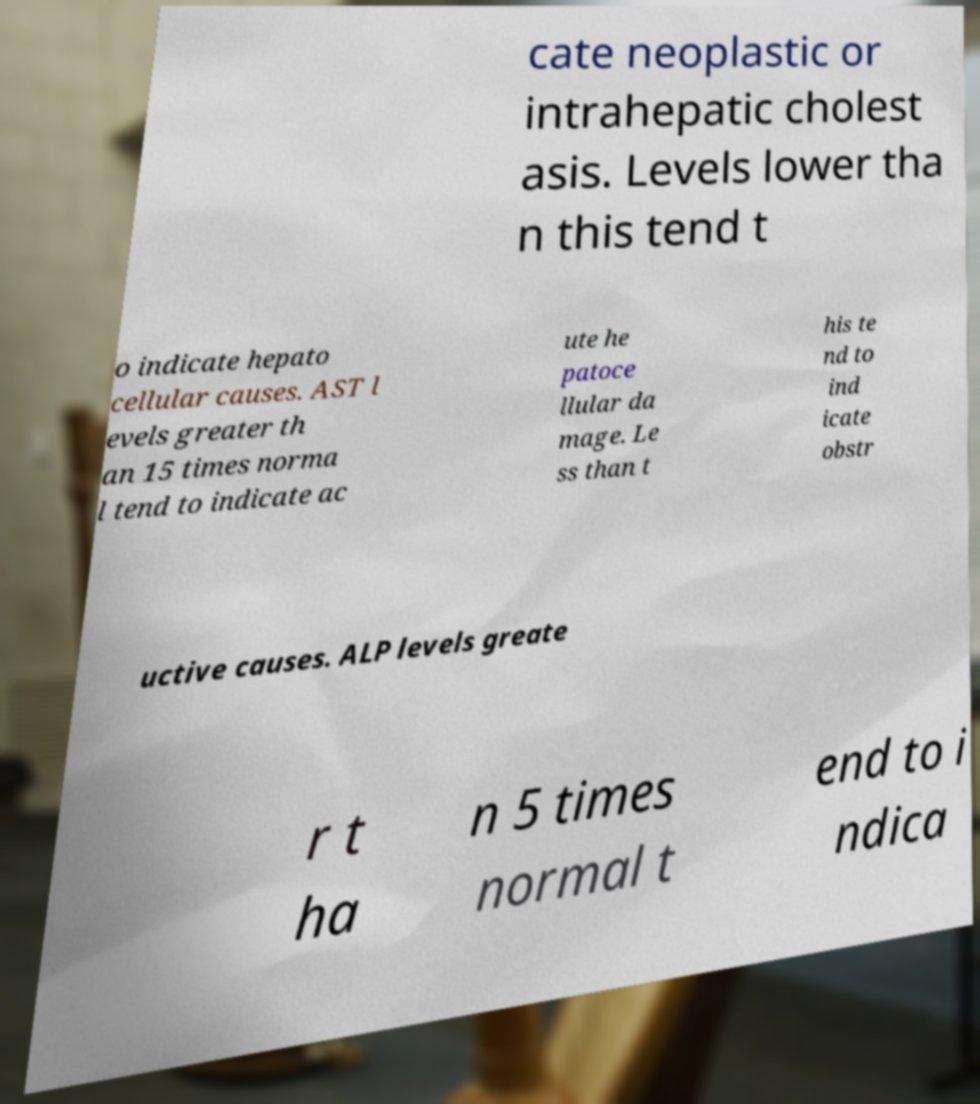Please read and relay the text visible in this image. What does it say? cate neoplastic or intrahepatic cholest asis. Levels lower tha n this tend t o indicate hepato cellular causes. AST l evels greater th an 15 times norma l tend to indicate ac ute he patoce llular da mage. Le ss than t his te nd to ind icate obstr uctive causes. ALP levels greate r t ha n 5 times normal t end to i ndica 